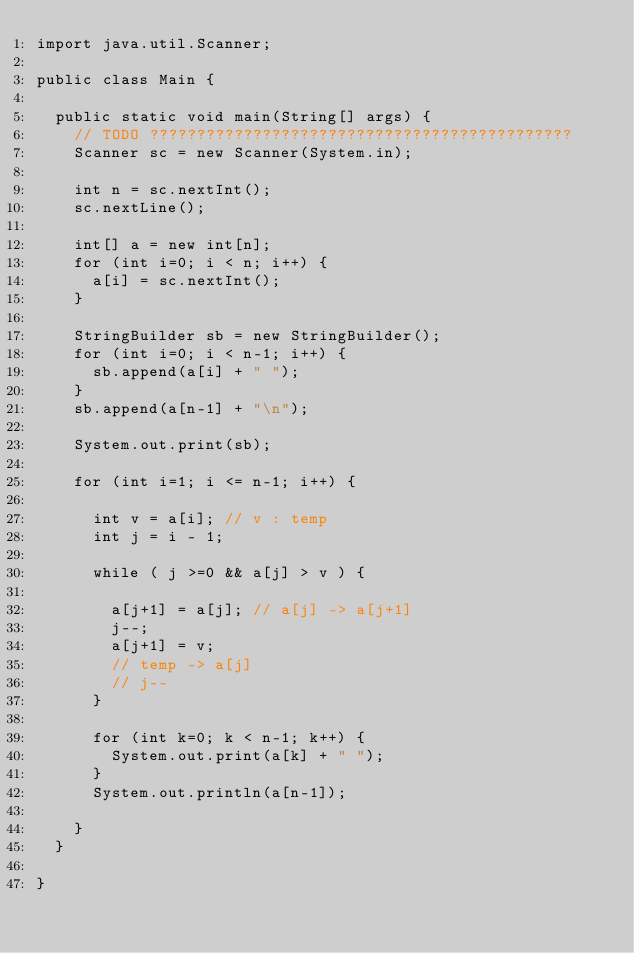Convert code to text. <code><loc_0><loc_0><loc_500><loc_500><_Java_>import java.util.Scanner;

public class Main {

	public static void main(String[] args) {
		// TODO ?????????????????????????????????????????????
		Scanner sc = new Scanner(System.in);

		int n = sc.nextInt();
		sc.nextLine();

		int[] a = new int[n];
		for (int i=0; i < n; i++) {
			a[i] = sc.nextInt();
		}

		StringBuilder sb = new StringBuilder();
		for (int i=0; i < n-1; i++) {
			sb.append(a[i] + " ");
		}
		sb.append(a[n-1] + "\n");

		System.out.print(sb);

		for (int i=1; i <= n-1; i++) {

			int v = a[i]; // v : temp
			int j = i - 1;

			while ( j >=0 && a[j] > v ) {

				a[j+1] = a[j]; // a[j] -> a[j+1]
				j--;
				a[j+1] = v;
				// temp -> a[j]
				// j--
			}

			for (int k=0; k < n-1; k++) {
				System.out.print(a[k] + " ");
			}
			System.out.println(a[n-1]);

		}
	}

}</code> 